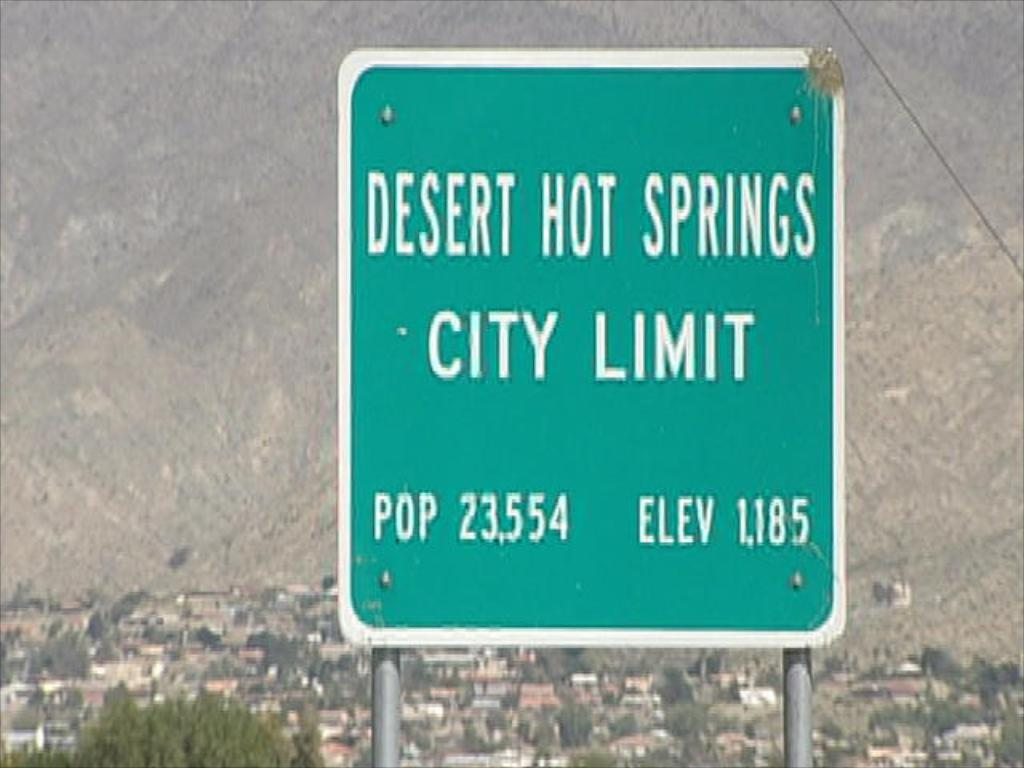<image>
Write a terse but informative summary of the picture. A traffic sign for Desert Hot Springs City Limit. 